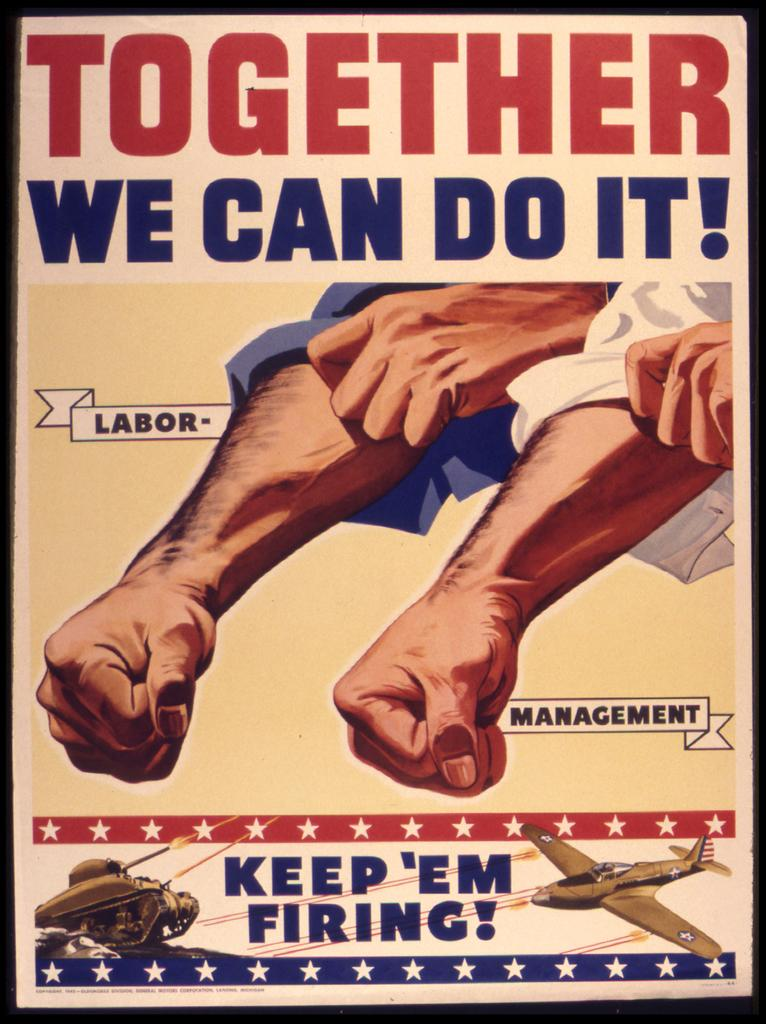What is the main object in the image? There is a pamphlet in the image. What can be seen on the pamphlet? There is an aeroplane depicted on the pamphlet. What is the purpose of the two hands visible in the image? The purpose of the two hands is not clear from the image, but they might be holding or interacting with the pamphlet. How is the writing on the pamphlet presented? The writing on the pamphlet is using different colors. How many babies are crawling on the box in the image? There is no box or babies present in the image. Are there any spiders crawling on the pamphlet in the image? There are no spiders visible on the pamphlet in the image. 